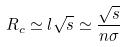Convert formula to latex. <formula><loc_0><loc_0><loc_500><loc_500>R _ { c } \simeq l \sqrt { s } \simeq \frac { \sqrt { s } } { n \sigma }</formula> 